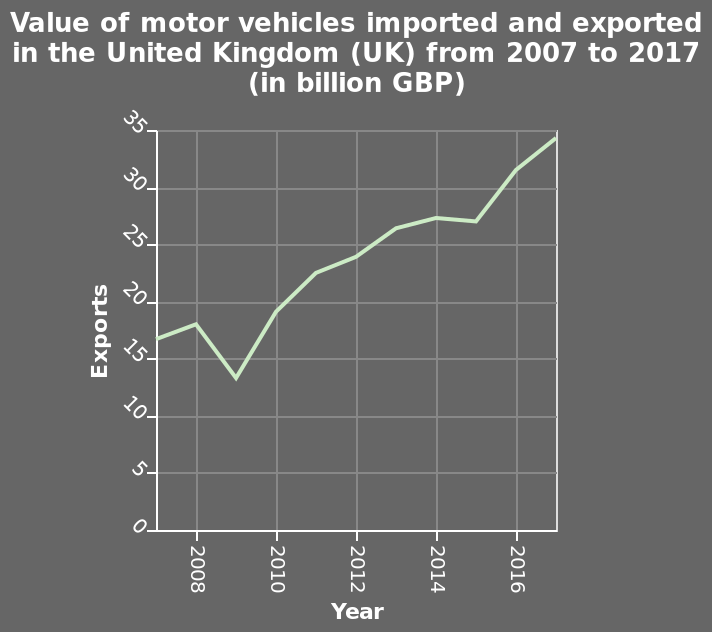<image>
please summary the statistics and relations of the chart Over the last ten years the general trend of value for Exports has trended upwards. The number  of exports  from Great Britain more than doubled by 2017.  From 2009 to 2010 is the year with the largest increase in percentage of exports.  2008 to 2009 is the year with the largest decrease in percentage of motor vehicle exports.  From 2014 to 2015 was they year with the least amount of change in percent of motor vehicles exported. Describe the following image in detail This is a line graph labeled Value of motor vehicles imported and exported in the United Kingdom (UK) from 2007 to 2017 (in billion GBP). Exports is measured as a linear scale of range 0 to 35 along the y-axis. Year is measured on the x-axis. Which year had the largest decrease in percentage of motor vehicle exports from 2008 to 2009? The year with the largest decrease in percentage of motor vehicle exports was 2008 to 2009. 